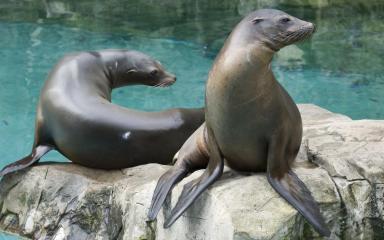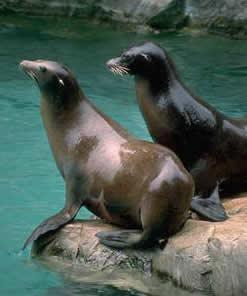The first image is the image on the left, the second image is the image on the right. For the images shown, is this caption "There is exactly one seal sitting on a rock in the image on the right." true? Answer yes or no. No. 